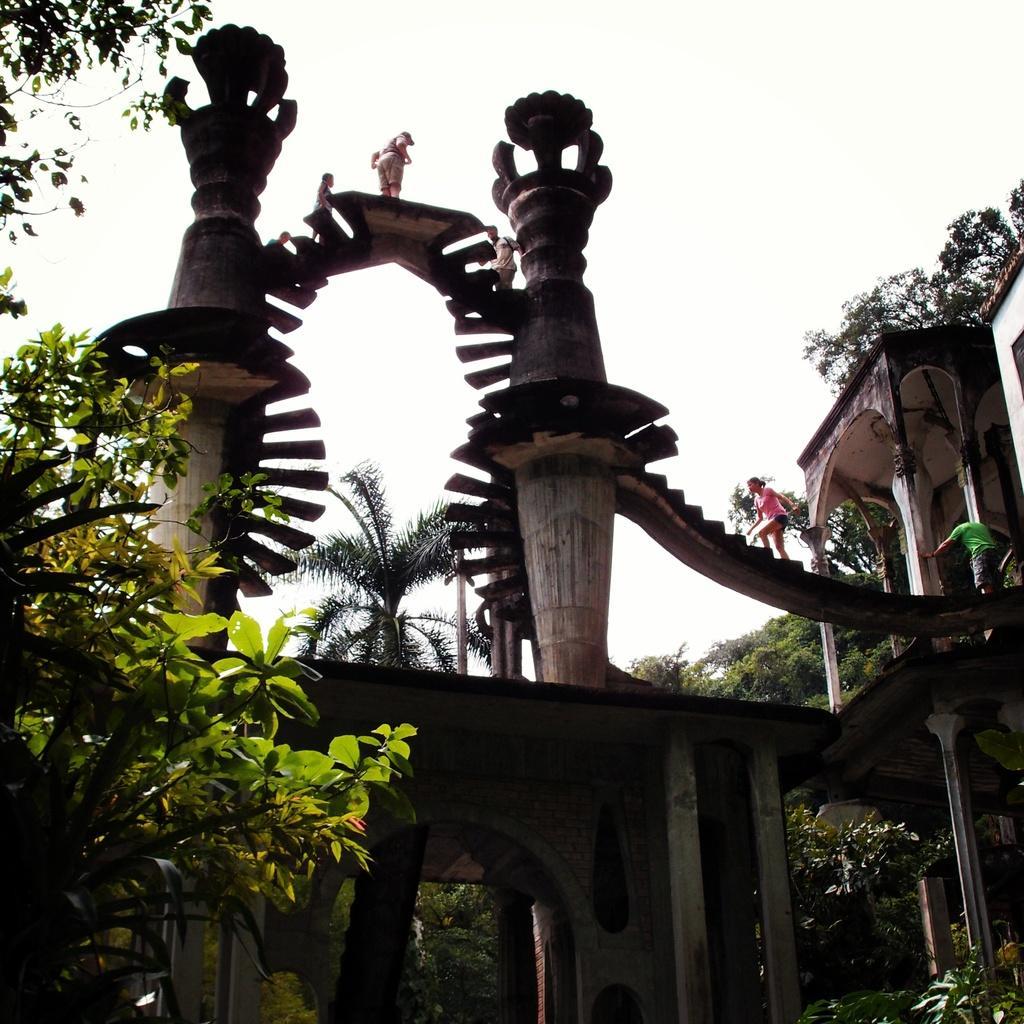In one or two sentences, can you explain what this image depicts? In this picture I can see an arch with pillars and stairs, there are few people standing on the stairs, there are trees, and in the background there is the sky. 